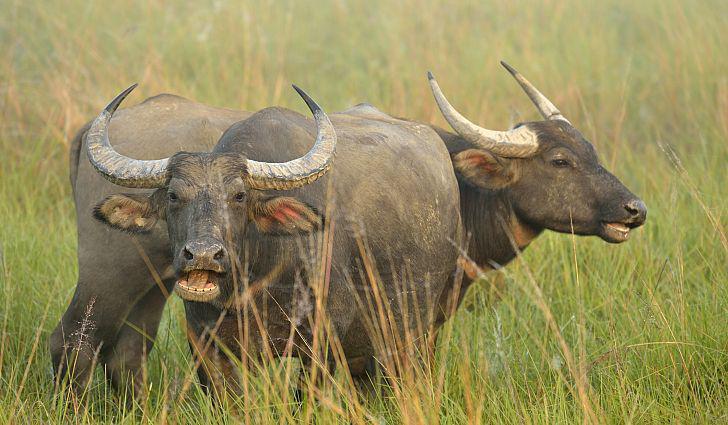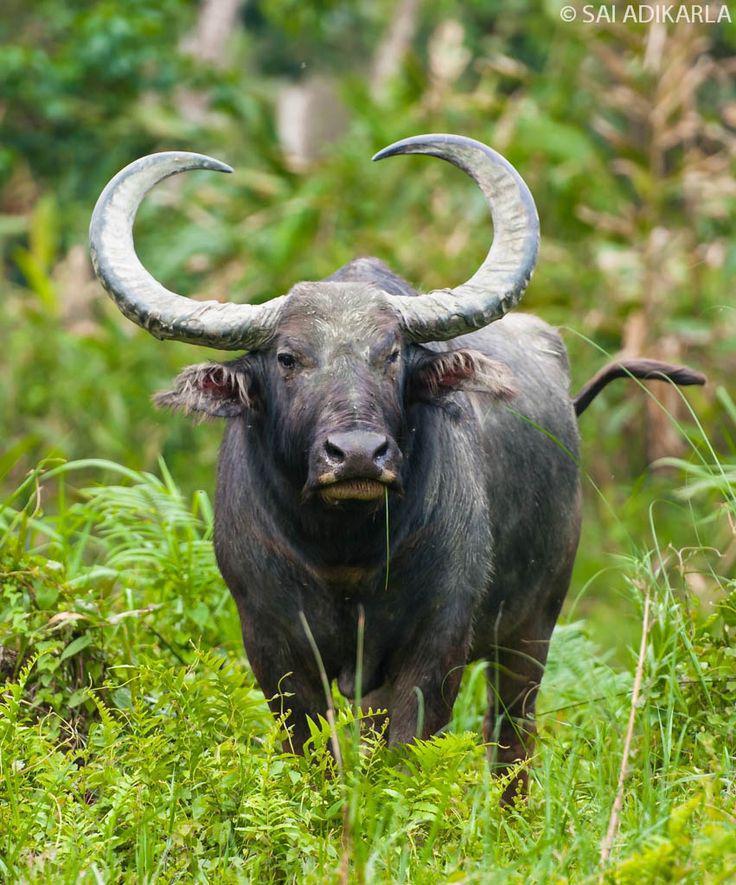The first image is the image on the left, the second image is the image on the right. Given the left and right images, does the statement "There are no more than 3 water buffalo in the pair of images" hold true? Answer yes or no. Yes. The first image is the image on the left, the second image is the image on the right. Examine the images to the left and right. Is the description "At least 3 cows are standing in a grassy field." accurate? Answer yes or no. Yes. 